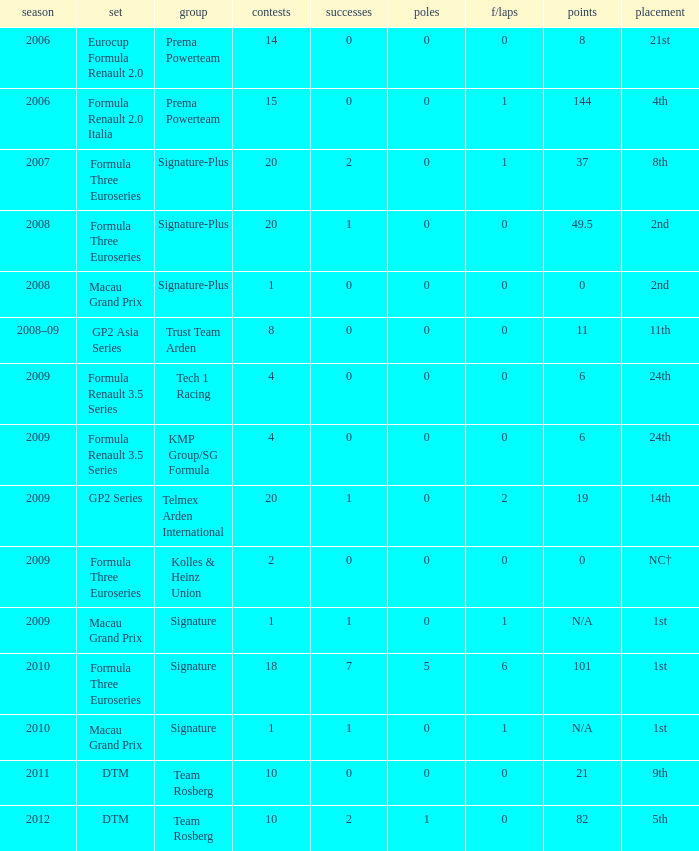How many poles are there in the Formula Three Euroseries in the 2008 season with more than 0 F/Laps? None. 